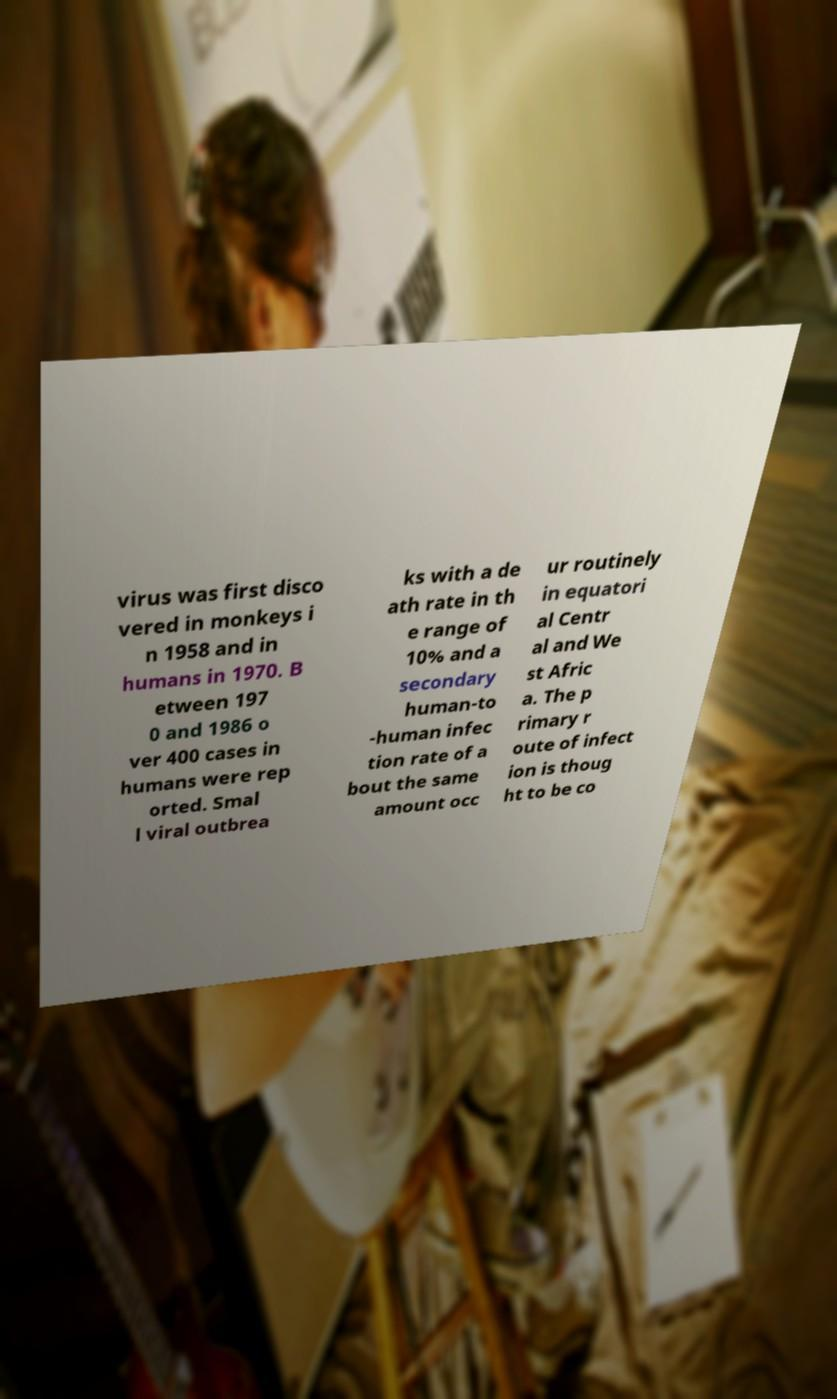Please read and relay the text visible in this image. What does it say? virus was first disco vered in monkeys i n 1958 and in humans in 1970. B etween 197 0 and 1986 o ver 400 cases in humans were rep orted. Smal l viral outbrea ks with a de ath rate in th e range of 10% and a secondary human-to -human infec tion rate of a bout the same amount occ ur routinely in equatori al Centr al and We st Afric a. The p rimary r oute of infect ion is thoug ht to be co 